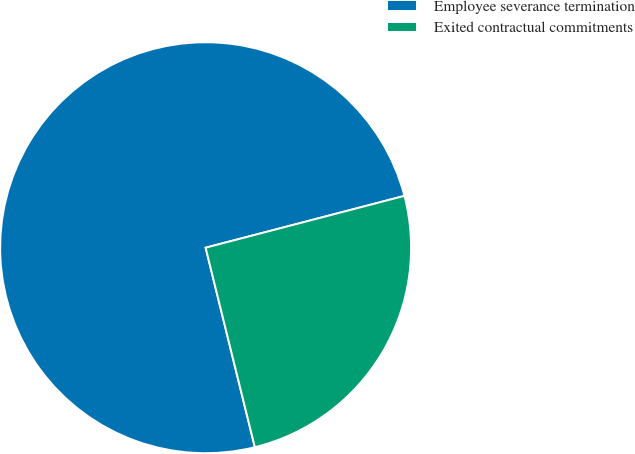Convert chart. <chart><loc_0><loc_0><loc_500><loc_500><pie_chart><fcel>Employee severance termination<fcel>Exited contractual commitments<nl><fcel>74.79%<fcel>25.21%<nl></chart> 